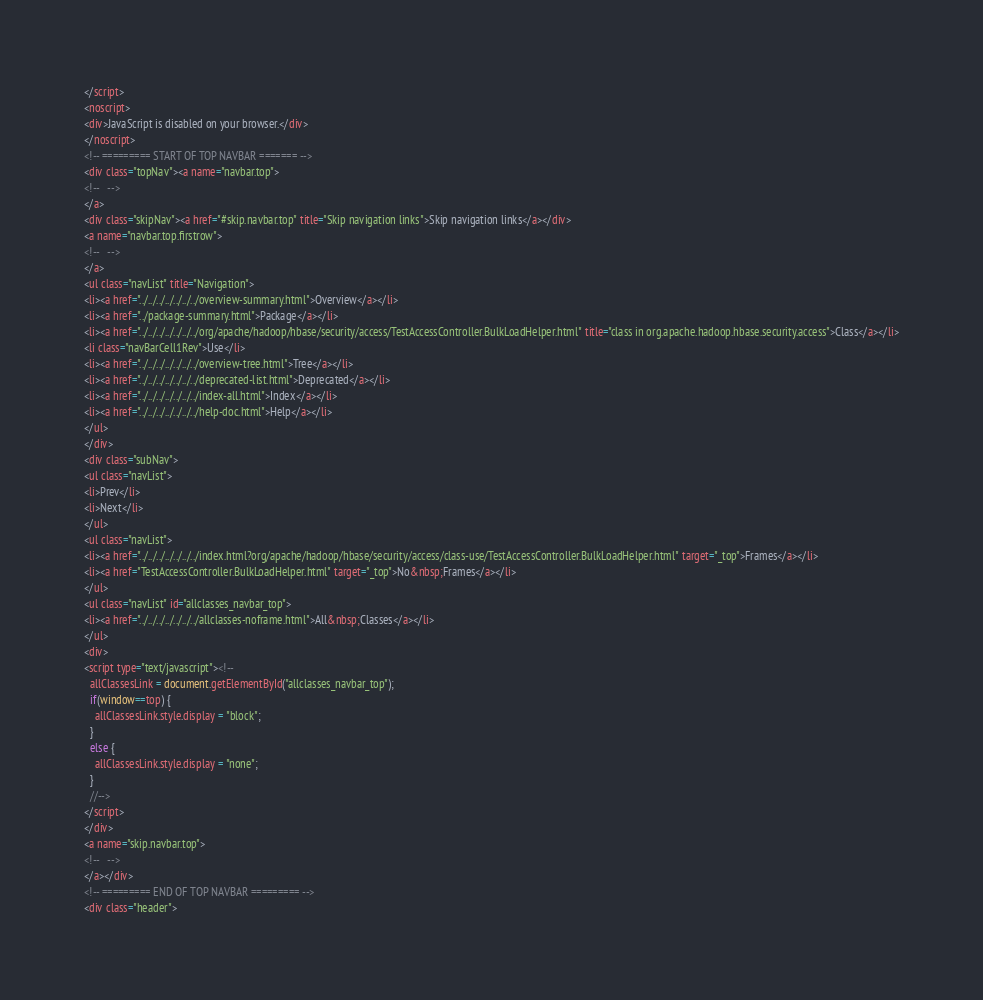Convert code to text. <code><loc_0><loc_0><loc_500><loc_500><_HTML_></script>
<noscript>
<div>JavaScript is disabled on your browser.</div>
</noscript>
<!-- ========= START OF TOP NAVBAR ======= -->
<div class="topNav"><a name="navbar.top">
<!--   -->
</a>
<div class="skipNav"><a href="#skip.navbar.top" title="Skip navigation links">Skip navigation links</a></div>
<a name="navbar.top.firstrow">
<!--   -->
</a>
<ul class="navList" title="Navigation">
<li><a href="../../../../../../../overview-summary.html">Overview</a></li>
<li><a href="../package-summary.html">Package</a></li>
<li><a href="../../../../../../../org/apache/hadoop/hbase/security/access/TestAccessController.BulkLoadHelper.html" title="class in org.apache.hadoop.hbase.security.access">Class</a></li>
<li class="navBarCell1Rev">Use</li>
<li><a href="../../../../../../../overview-tree.html">Tree</a></li>
<li><a href="../../../../../../../deprecated-list.html">Deprecated</a></li>
<li><a href="../../../../../../../index-all.html">Index</a></li>
<li><a href="../../../../../../../help-doc.html">Help</a></li>
</ul>
</div>
<div class="subNav">
<ul class="navList">
<li>Prev</li>
<li>Next</li>
</ul>
<ul class="navList">
<li><a href="../../../../../../../index.html?org/apache/hadoop/hbase/security/access/class-use/TestAccessController.BulkLoadHelper.html" target="_top">Frames</a></li>
<li><a href="TestAccessController.BulkLoadHelper.html" target="_top">No&nbsp;Frames</a></li>
</ul>
<ul class="navList" id="allclasses_navbar_top">
<li><a href="../../../../../../../allclasses-noframe.html">All&nbsp;Classes</a></li>
</ul>
<div>
<script type="text/javascript"><!--
  allClassesLink = document.getElementById("allclasses_navbar_top");
  if(window==top) {
    allClassesLink.style.display = "block";
  }
  else {
    allClassesLink.style.display = "none";
  }
  //-->
</script>
</div>
<a name="skip.navbar.top">
<!--   -->
</a></div>
<!-- ========= END OF TOP NAVBAR ========= -->
<div class="header"></code> 